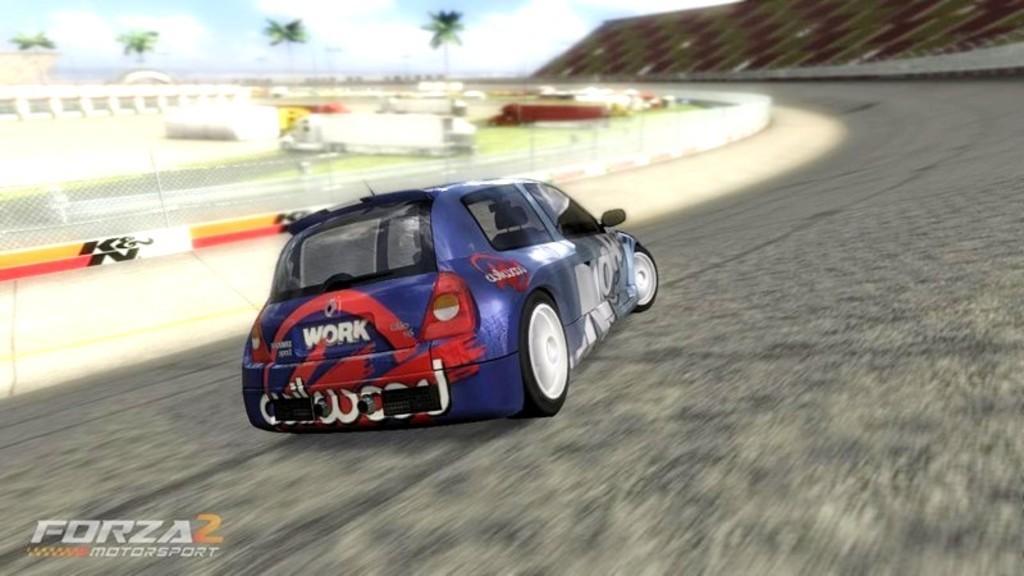Please provide a concise description of this image. It is an edited image. In this image there is a car on the road. On the left side of the image there is a metal fence. There are few objects on the surface. In the background of the image there are trees and sky. 